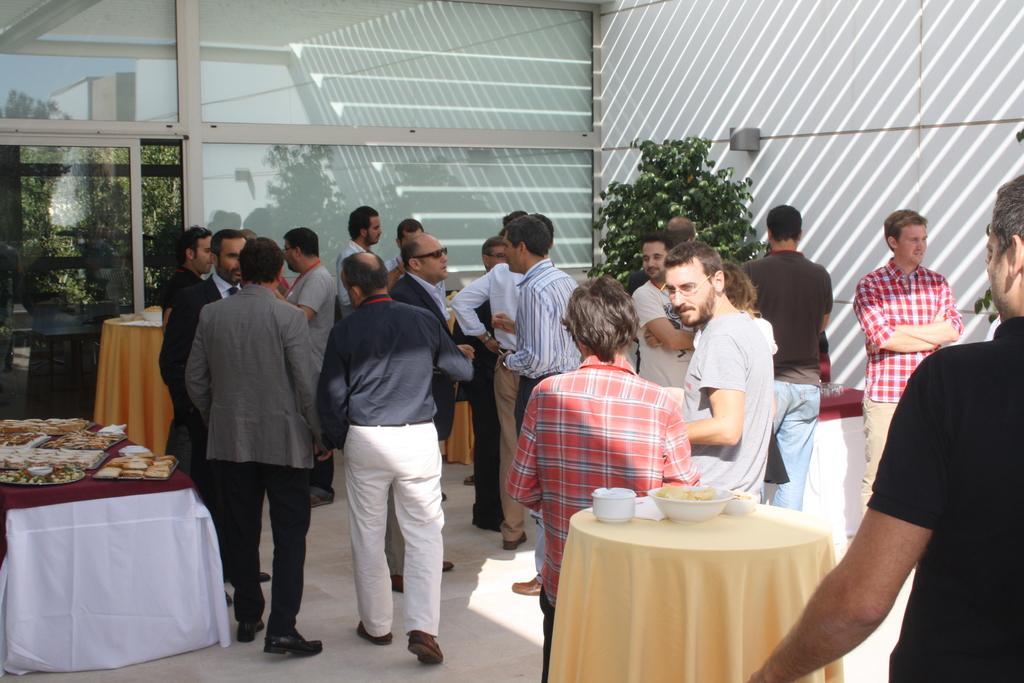Can you describe this image briefly? In this picture we can see all the men standing and talking near to the tables and on the table we can see food in a plates. This is a bowl. This is a plant. Through glass we can see a reflection of trees. 